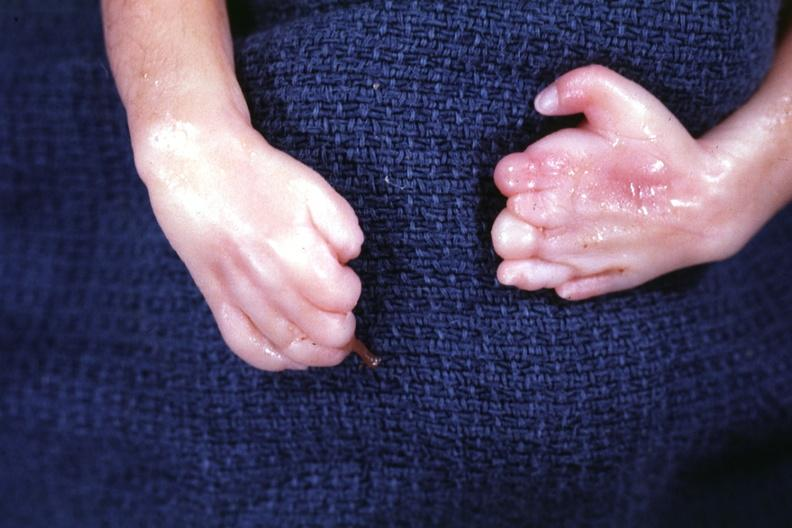re crookes cells present?
Answer the question using a single word or phrase. Yes 